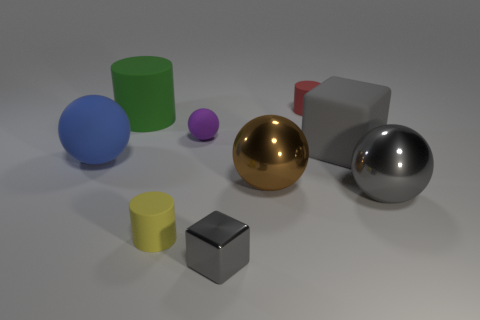Is the size of the gray object that is to the left of the red cylinder the same as the gray cube that is to the right of the small gray shiny block?
Keep it short and to the point. No. Is there a block to the left of the small matte thing in front of the small purple object?
Your response must be concise. No. There is a large brown metallic object; how many big gray matte blocks are on the right side of it?
Your answer should be very brief. 1. What number of other things are the same color as the large rubber block?
Offer a very short reply. 2. Is the number of large matte spheres to the right of the large gray ball less than the number of large green cylinders that are in front of the green matte object?
Offer a very short reply. No. What number of objects are gray things that are on the right side of the large matte cube or big shiny objects?
Your answer should be compact. 2. Do the gray shiny cube and the rubber ball right of the green matte cylinder have the same size?
Give a very brief answer. Yes. There is a gray thing that is the same shape as the big blue thing; what size is it?
Your answer should be very brief. Large. There is a small gray metal thing in front of the cylinder in front of the purple rubber sphere; what number of tiny cylinders are right of it?
Provide a short and direct response. 1. What number of cubes are large rubber things or big purple rubber objects?
Your response must be concise. 1. 